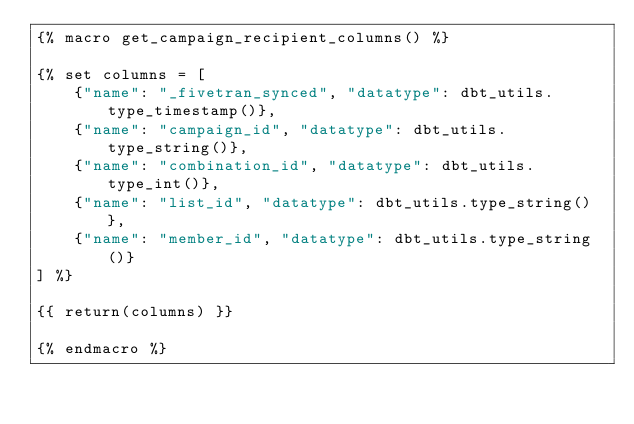<code> <loc_0><loc_0><loc_500><loc_500><_SQL_>{% macro get_campaign_recipient_columns() %}

{% set columns = [
    {"name": "_fivetran_synced", "datatype": dbt_utils.type_timestamp()},
    {"name": "campaign_id", "datatype": dbt_utils.type_string()},
    {"name": "combination_id", "datatype": dbt_utils.type_int()},
    {"name": "list_id", "datatype": dbt_utils.type_string()},
    {"name": "member_id", "datatype": dbt_utils.type_string()}
] %}

{{ return(columns) }}

{% endmacro %}</code> 